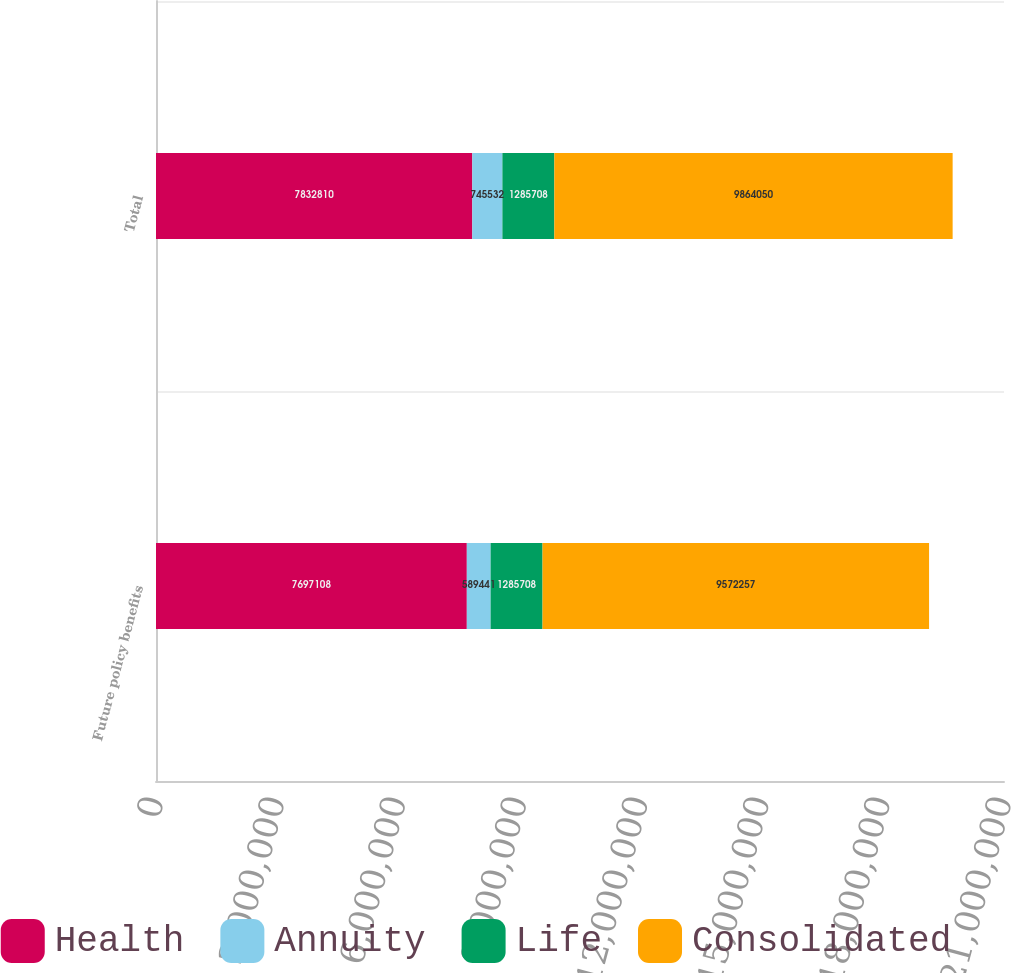Convert chart to OTSL. <chart><loc_0><loc_0><loc_500><loc_500><stacked_bar_chart><ecel><fcel>Future policy benefits<fcel>Total<nl><fcel>Health<fcel>7.69711e+06<fcel>7.83281e+06<nl><fcel>Annuity<fcel>589441<fcel>745532<nl><fcel>Life<fcel>1.28571e+06<fcel>1.28571e+06<nl><fcel>Consolidated<fcel>9.57226e+06<fcel>9.86405e+06<nl></chart> 